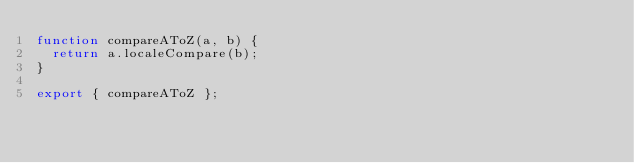<code> <loc_0><loc_0><loc_500><loc_500><_JavaScript_>function compareAToZ(a, b) {
  return a.localeCompare(b);
}

export { compareAToZ };
</code> 